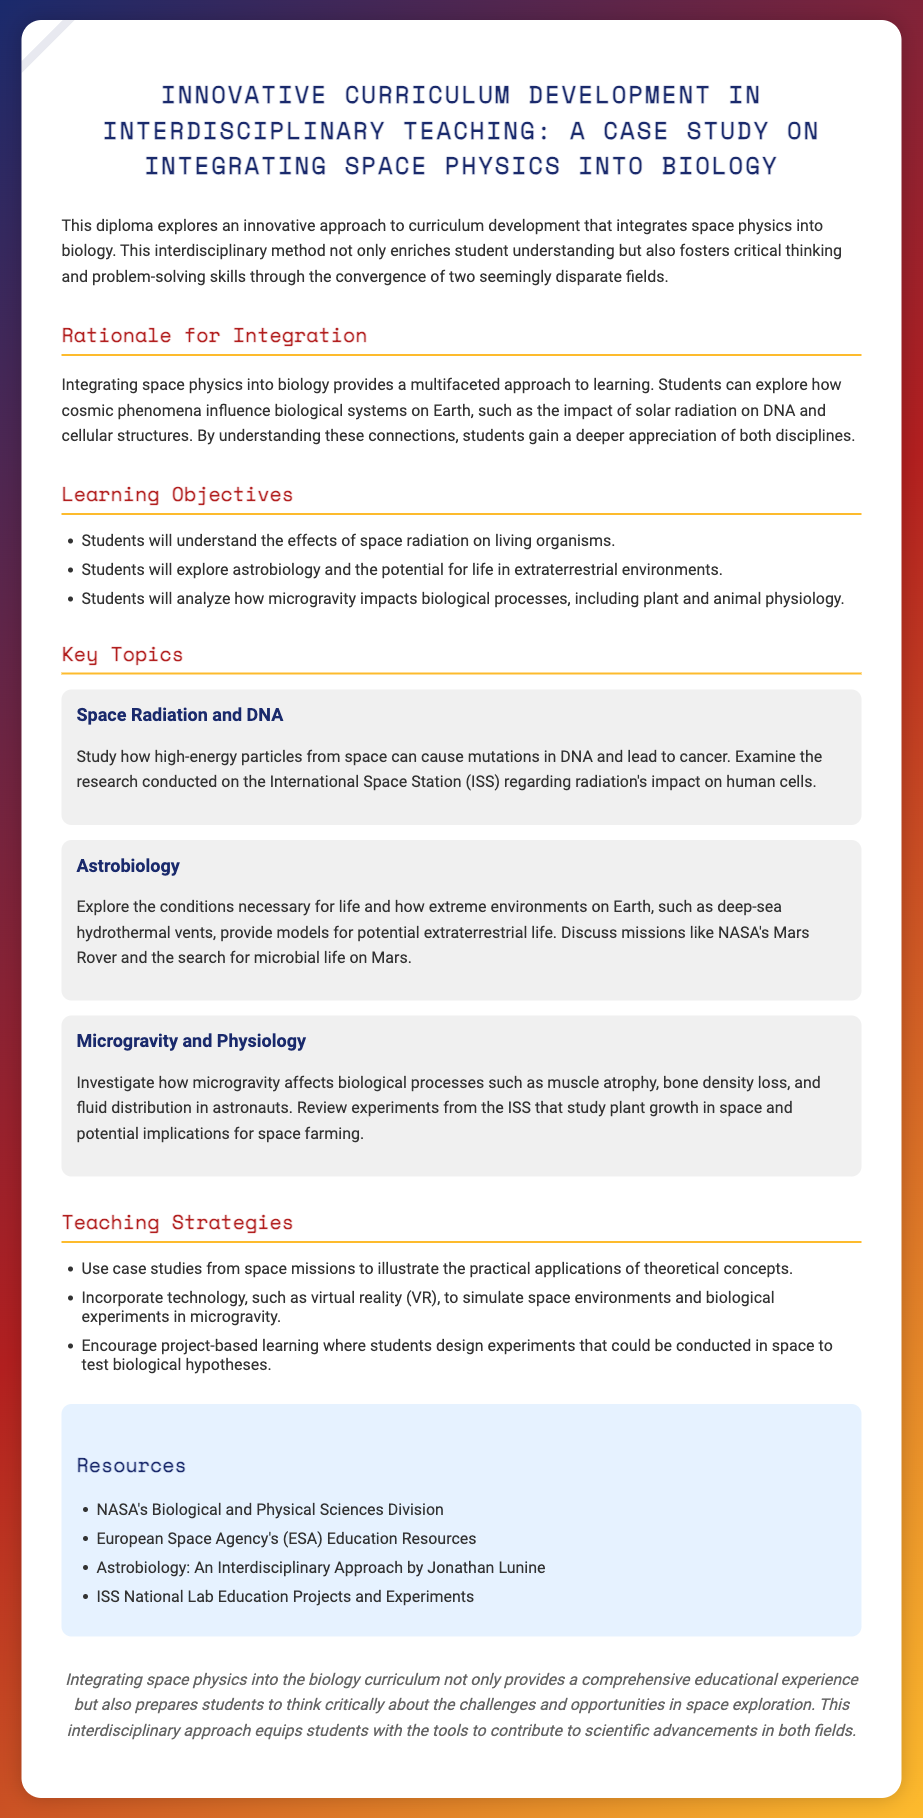what is the title of the diploma? The title of the diploma is provided at the top of the document.
Answer: Innovative Curriculum Development in Interdisciplinary Teaching: A Case Study on Integrating Space Physics into Biology what are the three key topics outlined in the document? The key topics are specifically mentioned in their respective sections.
Answer: Space Radiation and DNA, Astrobiology, Microgravity and Physiology how many learning objectives are listed in the document? The number of learning objectives is indicated in the section regarding them.
Answer: Three which organization’s resources are included in the document? Several resources are mentioned, specifically under the resources section.
Answer: NASA's Biological and Physical Sciences Division what does the document conclude about the integration of space physics into biology? The conclusion summarizes the benefits of integrating the two fields in education.
Answer: Provides a comprehensive educational experience 